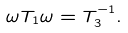<formula> <loc_0><loc_0><loc_500><loc_500>\omega T _ { 1 } \omega = T _ { 3 } ^ { - 1 } .</formula> 